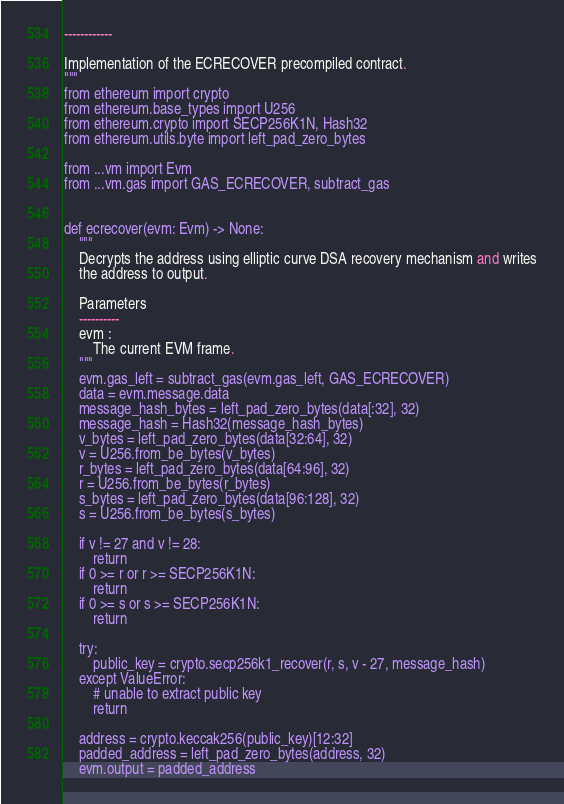Convert code to text. <code><loc_0><loc_0><loc_500><loc_500><_Python_>------------

Implementation of the ECRECOVER precompiled contract.
"""
from ethereum import crypto
from ethereum.base_types import U256
from ethereum.crypto import SECP256K1N, Hash32
from ethereum.utils.byte import left_pad_zero_bytes

from ...vm import Evm
from ...vm.gas import GAS_ECRECOVER, subtract_gas


def ecrecover(evm: Evm) -> None:
    """
    Decrypts the address using elliptic curve DSA recovery mechanism and writes
    the address to output.

    Parameters
    ----------
    evm :
        The current EVM frame.
    """
    evm.gas_left = subtract_gas(evm.gas_left, GAS_ECRECOVER)
    data = evm.message.data
    message_hash_bytes = left_pad_zero_bytes(data[:32], 32)
    message_hash = Hash32(message_hash_bytes)
    v_bytes = left_pad_zero_bytes(data[32:64], 32)
    v = U256.from_be_bytes(v_bytes)
    r_bytes = left_pad_zero_bytes(data[64:96], 32)
    r = U256.from_be_bytes(r_bytes)
    s_bytes = left_pad_zero_bytes(data[96:128], 32)
    s = U256.from_be_bytes(s_bytes)

    if v != 27 and v != 28:
        return
    if 0 >= r or r >= SECP256K1N:
        return
    if 0 >= s or s >= SECP256K1N:
        return

    try:
        public_key = crypto.secp256k1_recover(r, s, v - 27, message_hash)
    except ValueError:
        # unable to extract public key
        return

    address = crypto.keccak256(public_key)[12:32]
    padded_address = left_pad_zero_bytes(address, 32)
    evm.output = padded_address
</code> 